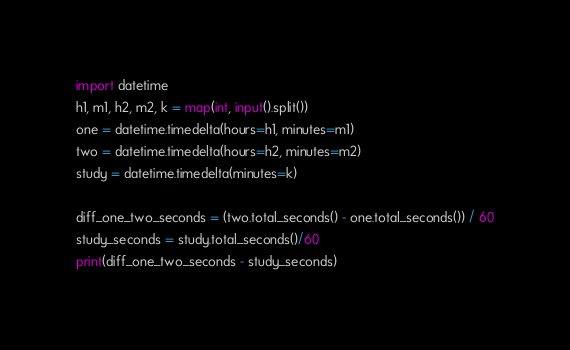<code> <loc_0><loc_0><loc_500><loc_500><_Python_>
import datetime
h1, m1, h2, m2, k = map(int, input().split())
one = datetime.timedelta(hours=h1, minutes=m1)
two = datetime.timedelta(hours=h2, minutes=m2)
study = datetime.timedelta(minutes=k)

diff_one_two_seconds = (two.total_seconds() - one.total_seconds()) / 60
study_seconds = study.total_seconds()/60
print(diff_one_two_seconds - study_seconds)</code> 